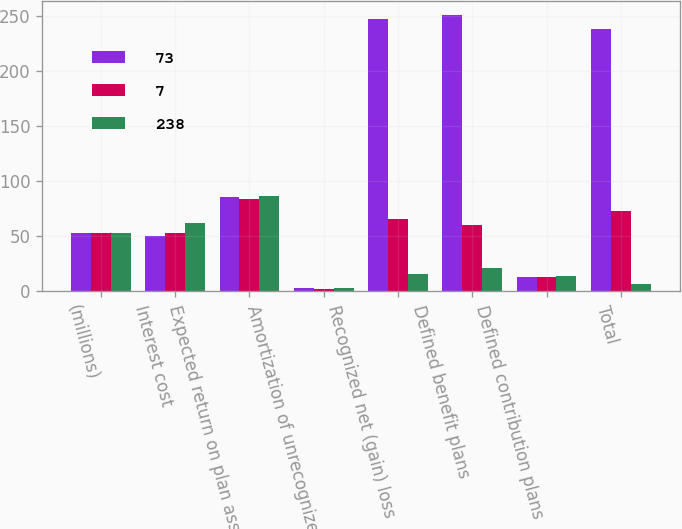Convert chart to OTSL. <chart><loc_0><loc_0><loc_500><loc_500><stacked_bar_chart><ecel><fcel>(millions)<fcel>Interest cost<fcel>Expected return on plan assets<fcel>Amortization of unrecognized<fcel>Recognized net (gain) loss<fcel>Defined benefit plans<fcel>Defined contribution plans<fcel>Total<nl><fcel>73<fcel>53<fcel>50<fcel>86<fcel>3<fcel>247<fcel>251<fcel>13<fcel>238<nl><fcel>7<fcel>53<fcel>53<fcel>84<fcel>2<fcel>66<fcel>60<fcel>13<fcel>73<nl><fcel>238<fcel>53<fcel>62<fcel>87<fcel>3<fcel>16<fcel>21<fcel>14<fcel>7<nl></chart> 